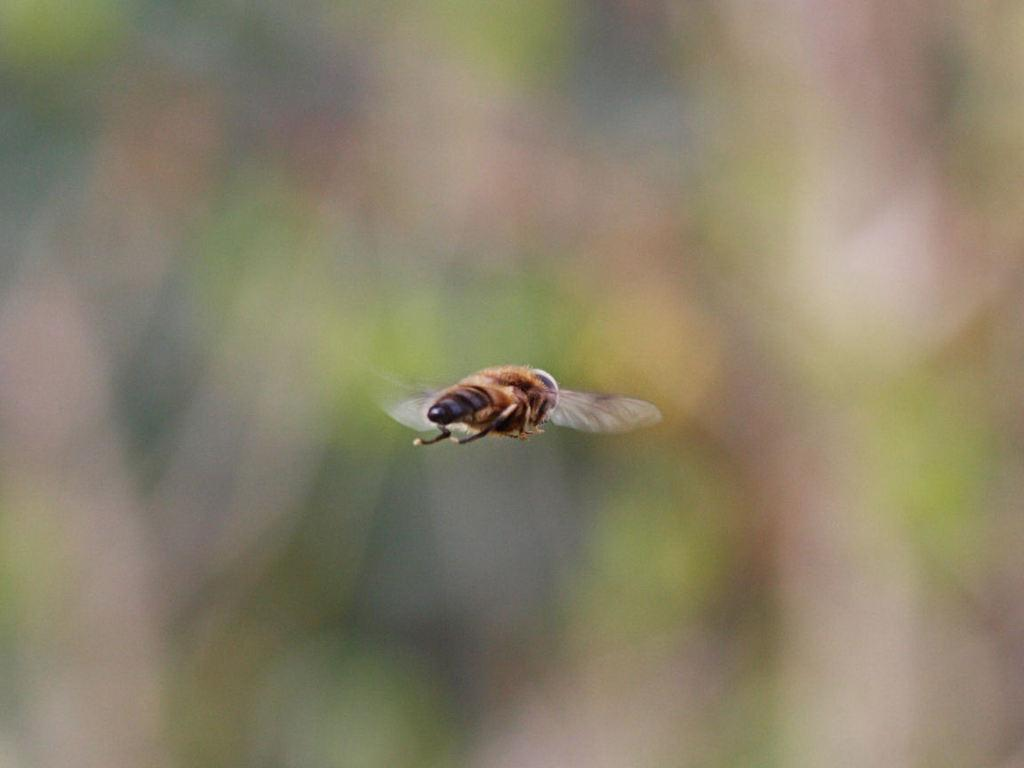What is the main subject of the image? There is a fly in the air in the center of the image. Can you describe the background of the image? The background of the image is blurry. What type of bean can be seen growing in the pocket of the person in the image? There is no person or bean present in the image; it features a fly in the air with a blurry background. 